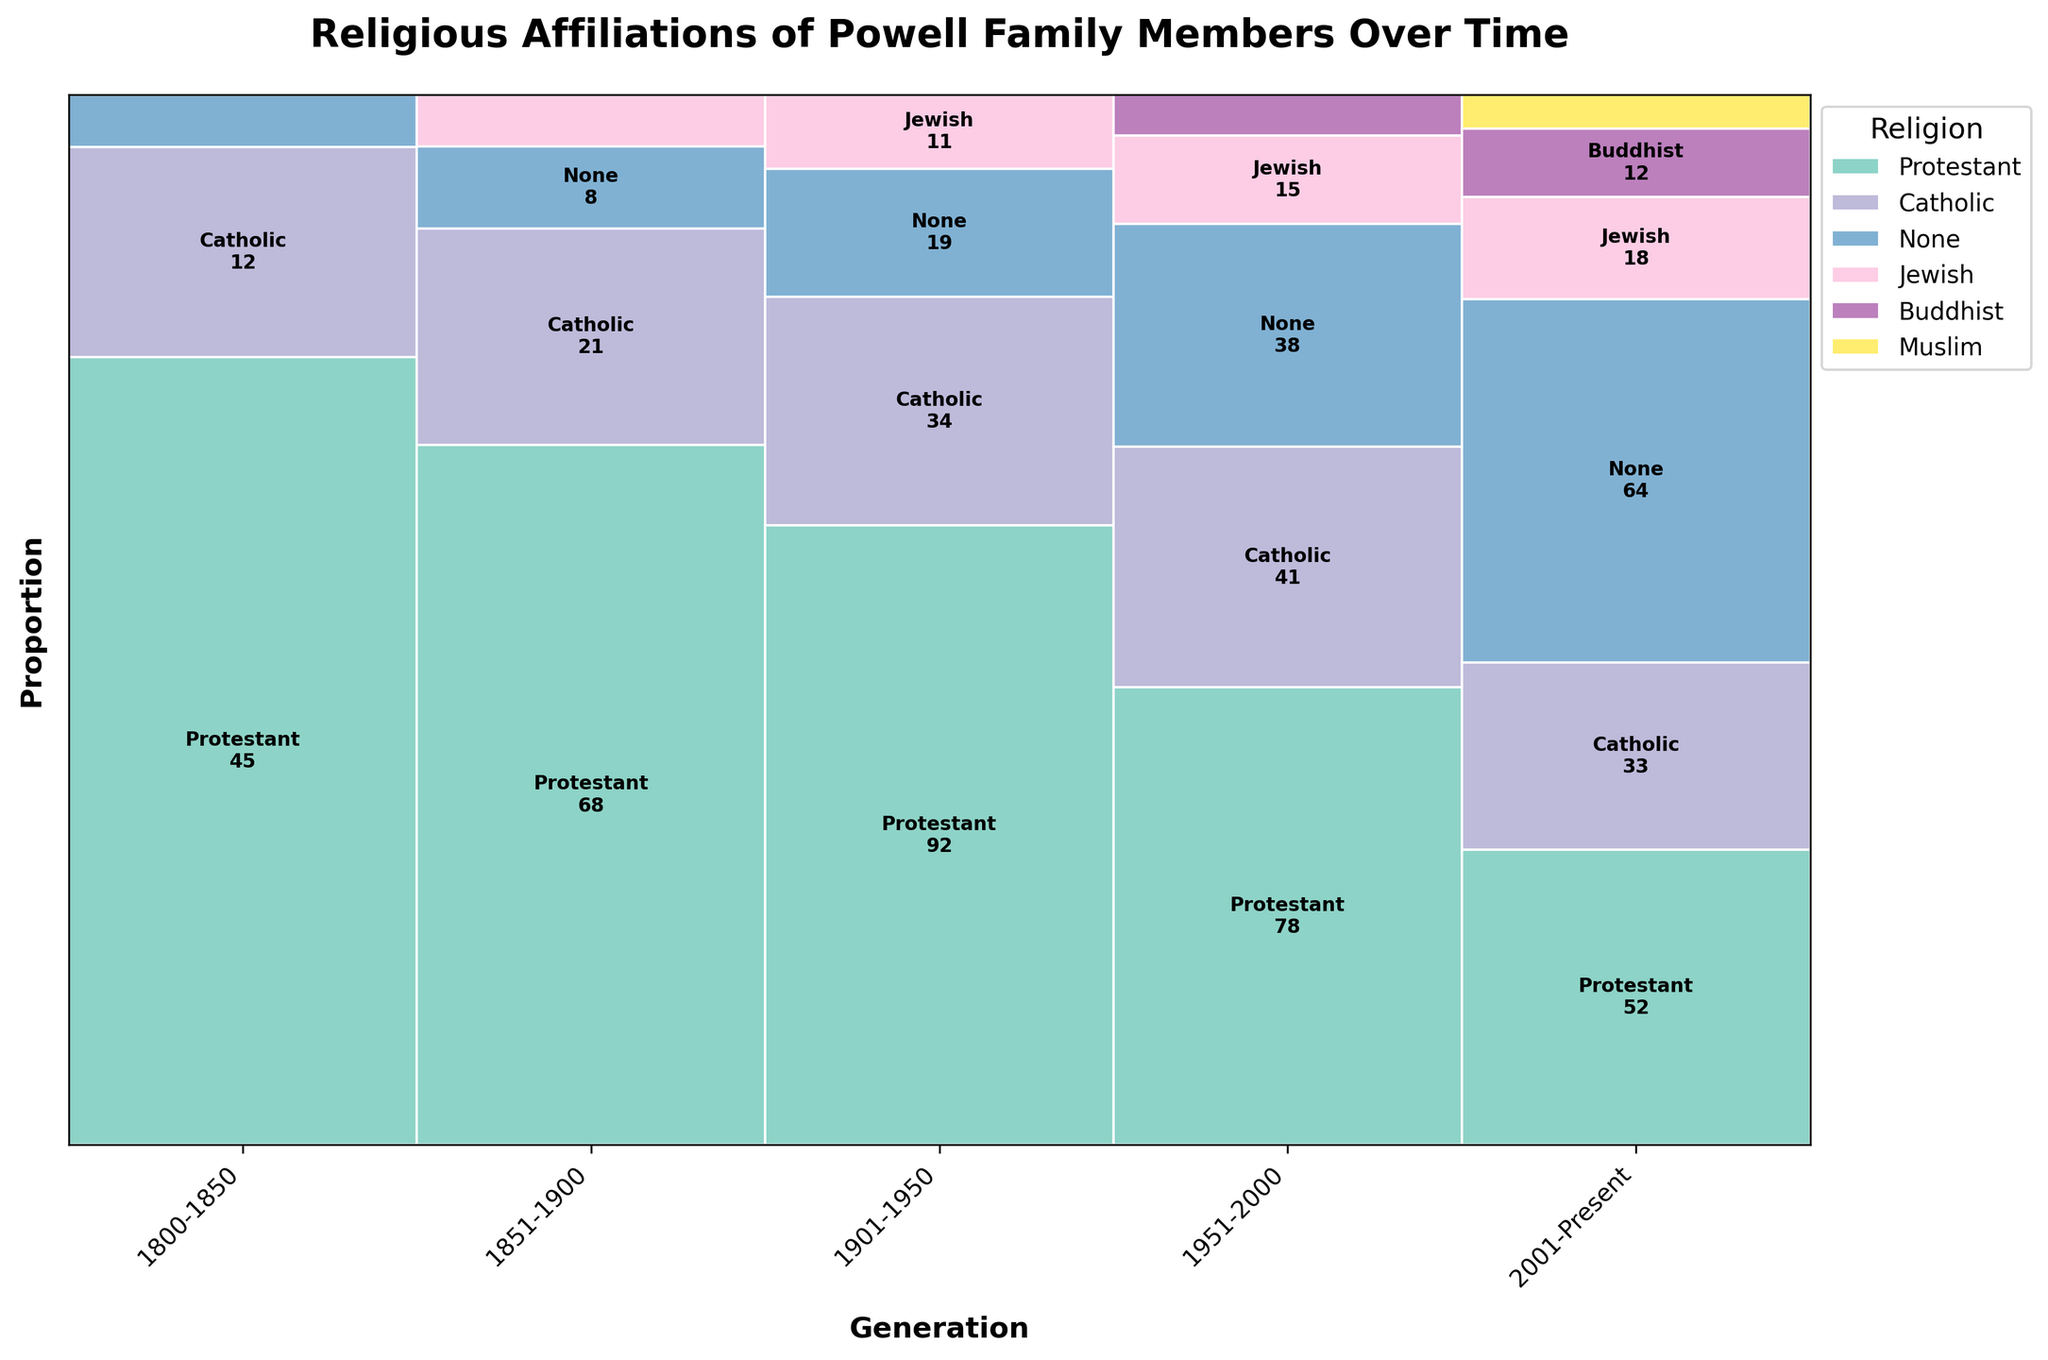How many generations are shown in the plot? There are six generations listed on the x-axis. They are '1800-1850', '1851-1900', '1901-1950', '1951-2000', and '2001-Present'.
Answer: 6 Which religion appears for the first time in the '1901-1950' generation? Jewish and None already appear in the '1851-1900' generation. Protestant and Catholic were present in '1800-1850'.
Answer: Jewish, None What is the most prominent religion in the '2001-Present' generation? The plot shows the highest proportion for 'None' in the '2001-Present' generation.
Answer: None How did the proportion of Protestant followers change from '1800-1850' to '2001-Present'? In '1800-1850', the Protestant proportion is a larger section of the plot compared to the overall section in the '2001-Present' generation.
Answer: Decrease Which generation has the highest number of religions represented? By counting the different colors present in each generation, '2001-Present' has five different religions represented while other generations have fewer.
Answer: 2001-Present What are the new religions that appeared in the '2001-Present' generation? Comparing the previous generations, 'Muslim' appears for the first time in the '2001-Present' generation.
Answer: Muslim Was the 'None' category present in every generation? By looking through each generation representation, the 'None' category appears from the '1800-1850' generation and continues through the generations.
Answer: Yes How does the proportion of Catholics change from '1951-2000' to '2001-Present'? The proportion of Catholics shown in the plot decreases slightly from '1951-2000' to '2001-Present'.
Answer: Decrease Which religion showed up first in the Powell family based on the plot? In the '1800-1850' generation, only Protestant and Catholic were shown in the plot.
Answer: Protestant, Catholic 